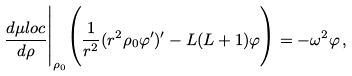<formula> <loc_0><loc_0><loc_500><loc_500>\frac { d \mu l o c } { d \rho } \Big | _ { \rho _ { 0 } } \Big ( \frac { 1 } { r ^ { 2 } } ( r ^ { 2 } \rho _ { 0 } \varphi ^ { \prime } ) ^ { \prime } - L ( L + 1 ) \varphi \Big ) = - \omega ^ { 2 } \varphi \, ,</formula> 